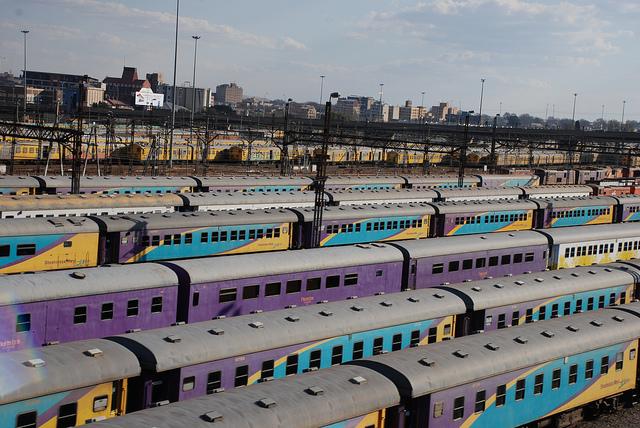What is the dominant color palette on the trains?
Give a very brief answer. Purple. Are there clouds in the sky?
Write a very short answer. Yes. What does a set of dominoes have in common with these trains?
Short answer required. Lined up. 